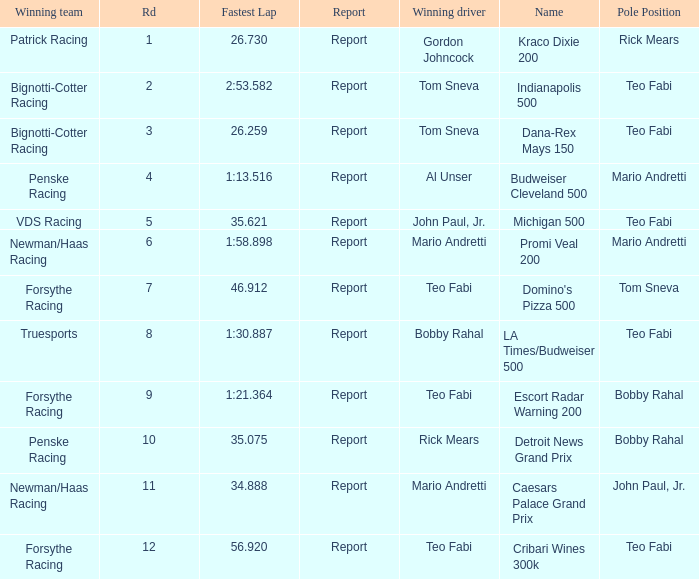How many winning drivers were there in the race that had a fastest lap time of 56.920? 1.0. 